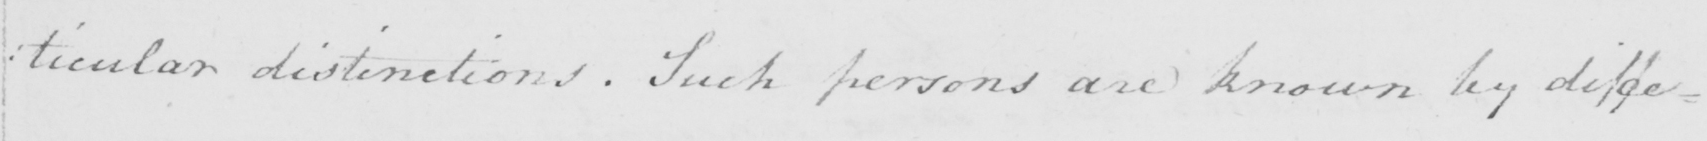Can you tell me what this handwritten text says? : ticular distinctions . Such persons are known by diffe= 